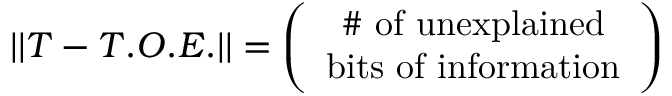<formula> <loc_0><loc_0><loc_500><loc_500>| | T - T . O . E . | | = \left ( \begin{array} { c } { \# o f u n e x p l a i n e d } \\ { b i t s o f i n f o r m a t i o n } \end{array} \right )</formula> 